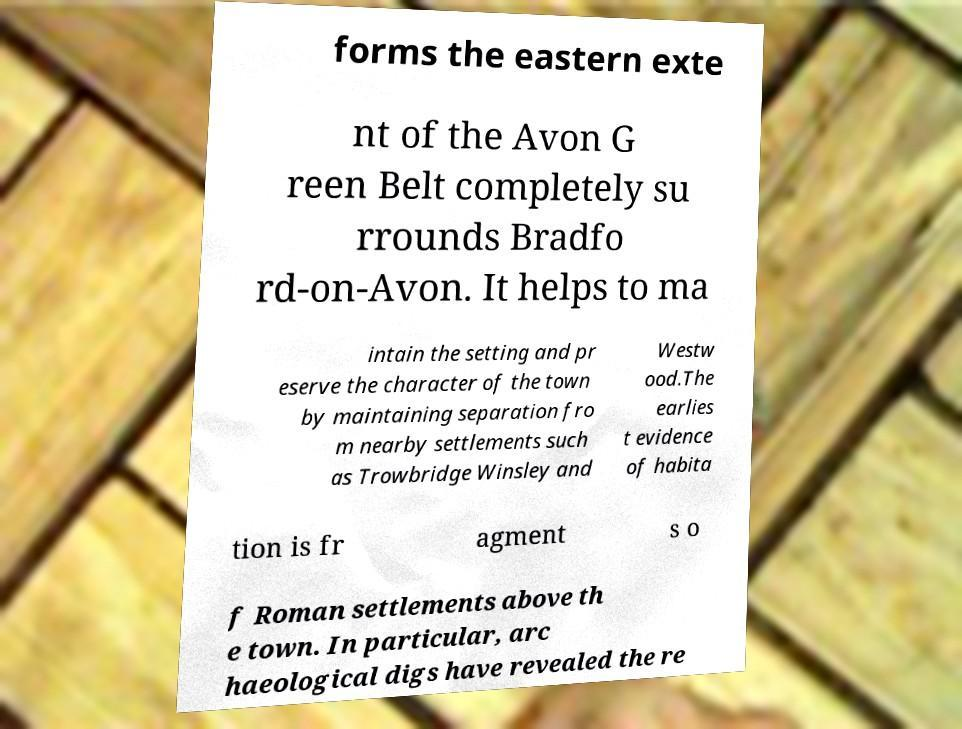Can you accurately transcribe the text from the provided image for me? forms the eastern exte nt of the Avon G reen Belt completely su rrounds Bradfo rd-on-Avon. It helps to ma intain the setting and pr eserve the character of the town by maintaining separation fro m nearby settlements such as Trowbridge Winsley and Westw ood.The earlies t evidence of habita tion is fr agment s o f Roman settlements above th e town. In particular, arc haeological digs have revealed the re 